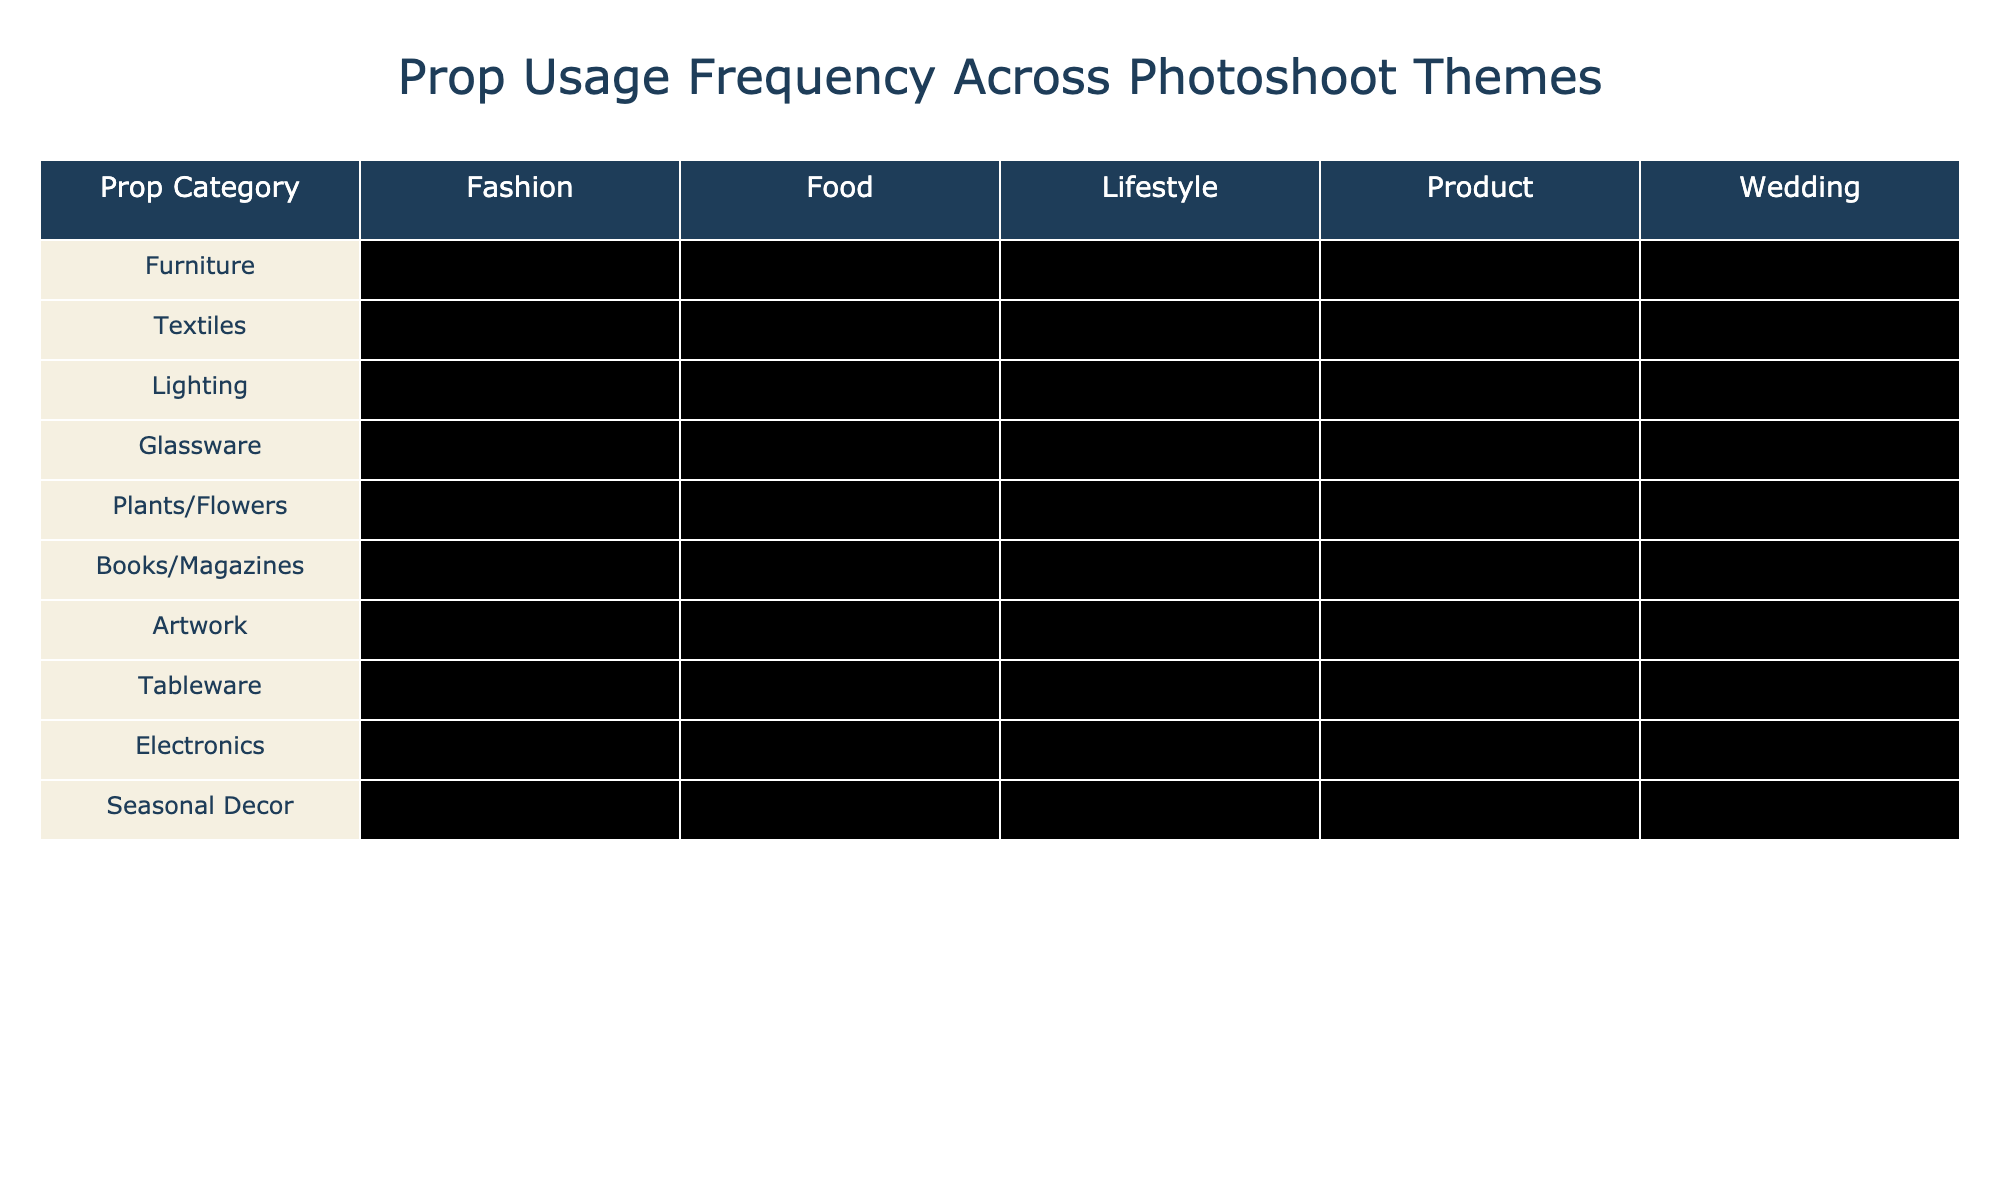What prop category is most frequently used in fashion photoshoots? The table shows that Lighting is used the most in fashion photoshoots at 95%.
Answer: Lighting Which prop category has the lowest usage in food photoshoots? The Glassware category has the lowest usage in food photoshoots at 30%.
Answer: Glassware Is Textiles used more in Lifestyle or Wedding themes? Textiles is used 70% in Lifestyle and 80% in Wedding, so it is used more in Wedding themes.
Answer: Yes What is the difference in usage frequency of Furniture between Lifestyle and Food photoshoots? Furniture usage is 90% in Lifestyle and 30% in Food, so the difference is 90% - 30% = 60%.
Answer: 60% What percentage of usage does Plants/Flowers have in Wedding compared to Electronics in Product photoshoots? Plants/Flowers is at 95% in Wedding and Electronics is at 85% in Product, so Plants/Flowers has a higher usage by 10%.
Answer: 10% In which photoshoot theme is Tableware used the least? The usage of Tableware is lowest in Lifestyle at 45%.
Answer: Lifestyle Which prop categories have at least 70% usage in Product photoshoots? The categories with at least 70% usage in Product are Lighting (90%), Electronics (85%), and Furniture (40%).
Answer: Lighting and Electronics Calculate the average usage frequency of Books/Magazines across all themes. The usage percentages for Books/Magazines are 20%, 10%, 75%, 15%, and 5%. Summing them gives 20 + 10 + 75 + 15 + 5 = 125, and dividing by 5 gives 125/5 = 25%.
Answer: 25% Which prop category has the highest overall usage frequency across all themes? By visual inspection or calculation, Lighting stands out as having the highest frequency at 95% in Fashion, so it is the most frequently used category overall.
Answer: Yes What is the total usage frequency for Furniture across all themes? Adding up the usage frequencies for Furniture: 75% + 30% + 90% + 40% + 60% = 295%. Dividing by 5 themes gives an average of 59%.
Answer: 59% 